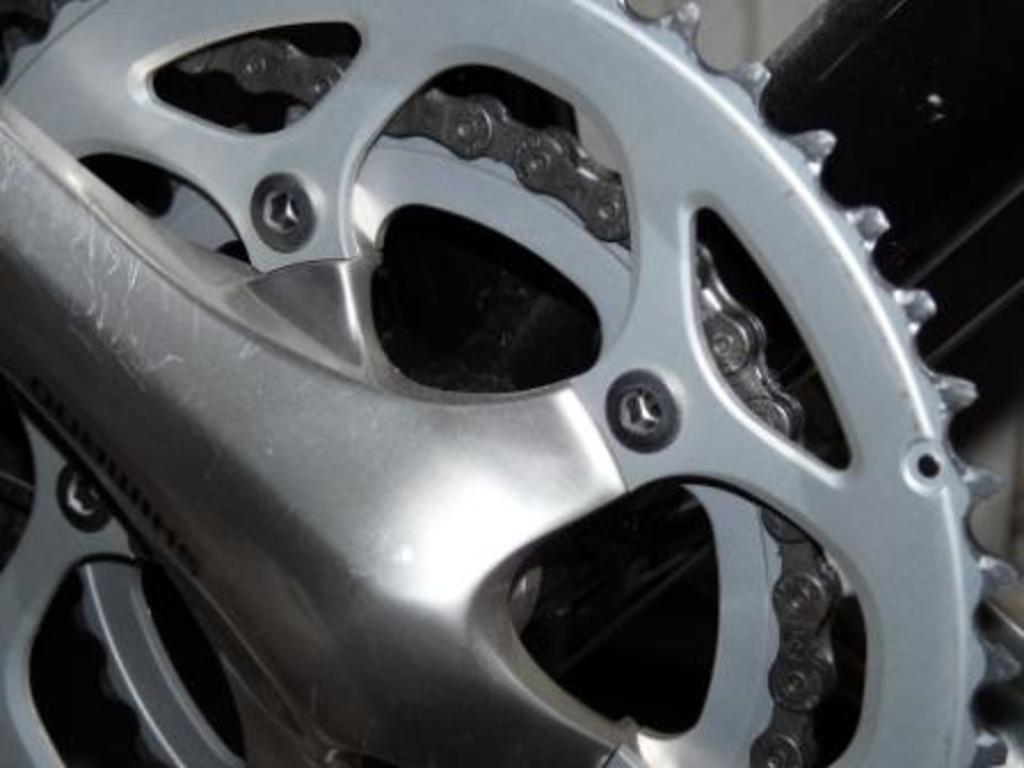What is located in the foreground of the image? There is a vehicles chain in the foreground of the image. What can be seen in the background of the image? There are objects visible in the background of the image. How much credit is given to the patch in the image? There is no patch present in the image, so credit cannot be given to it. 